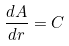Convert formula to latex. <formula><loc_0><loc_0><loc_500><loc_500>\frac { d A } { d r } = C</formula> 